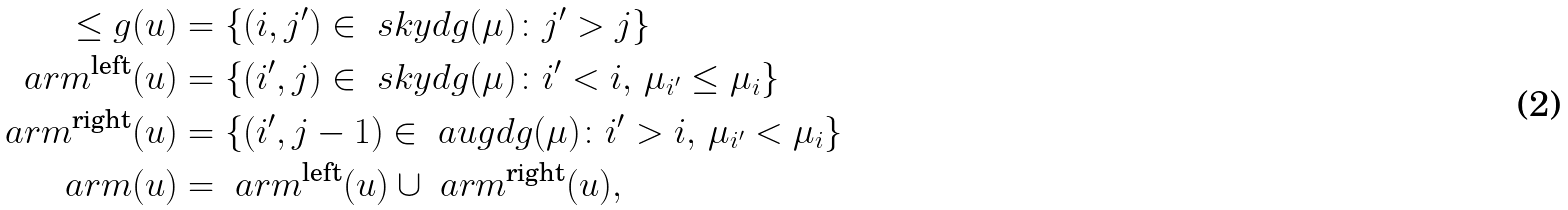Convert formula to latex. <formula><loc_0><loc_0><loc_500><loc_500>\leq g ( u ) & = \{ ( i , j ^ { \prime } ) \in \ s k y d g ( \mu ) \colon j ^ { \prime } > j \} \\ \ a r m ^ { \text {left} } ( u ) & = \{ ( i ^ { \prime } , j ) \in \ s k y d g ( \mu ) \colon i ^ { \prime } < i , \, \mu _ { i ^ { \prime } } \leq \mu _ { i } \} \\ \ a r m ^ { \text {right} } ( u ) & = \{ ( i ^ { \prime } , j - 1 ) \in \ a u g d g ( \mu ) \colon i ^ { \prime } > i , \, \mu _ { i ^ { \prime } } < \mu _ { i } \} \\ \ a r m ( u ) & = \ a r m ^ { \text {left} } ( u ) \cup \ a r m ^ { \text {right} } ( u ) ,</formula> 